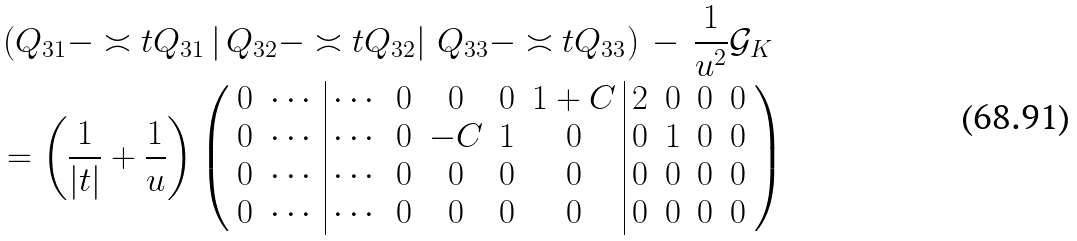Convert formula to latex. <formula><loc_0><loc_0><loc_500><loc_500>& \left ( Q _ { 3 1 } - \asymp t { Q } _ { 3 1 } \left | \, Q _ { 3 2 } - \asymp t { Q } _ { 3 2 } \right | \, Q _ { 3 3 } - \asymp t { Q } _ { 3 3 } \right ) \, - \, \frac { 1 } { u ^ { 2 } } \mathcal { G } _ { K } \\ & = \left ( \frac { 1 } { | t | } + \frac { 1 } { u } \right ) \left ( \begin{array} { c c | c c c c c | c c c c } 0 & \cdots & \cdots & 0 & 0 & 0 & 1 + C & 2 & 0 & 0 & 0 \\ 0 & \cdots & \cdots & 0 & - C & 1 & 0 & 0 & 1 & 0 & 0 \\ 0 & \cdots & \cdots & 0 & 0 & 0 & 0 & 0 & 0 & 0 & 0 \\ 0 & \cdots & \cdots & 0 & 0 & 0 & 0 & 0 & 0 & 0 & 0 \end{array} \right )</formula> 